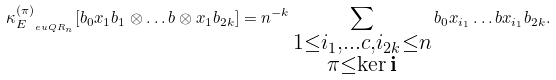<formula> <loc_0><loc_0><loc_500><loc_500>\kappa _ { E _ { \ e u { Q R } _ { n } } } ^ { ( \pi ) } [ b _ { 0 } x _ { 1 } b _ { 1 } \otimes \dots b \otimes x _ { 1 } b _ { 2 k } ] = n ^ { - k } \sum _ { \substack { 1 \leq i _ { 1 } , \dots c , i _ { 2 k } \leq n \\ \pi \leq \ker \mathbf i } } b _ { 0 } x _ { i _ { 1 } } \dots b x _ { i _ { 1 } } b _ { 2 k } .</formula> 